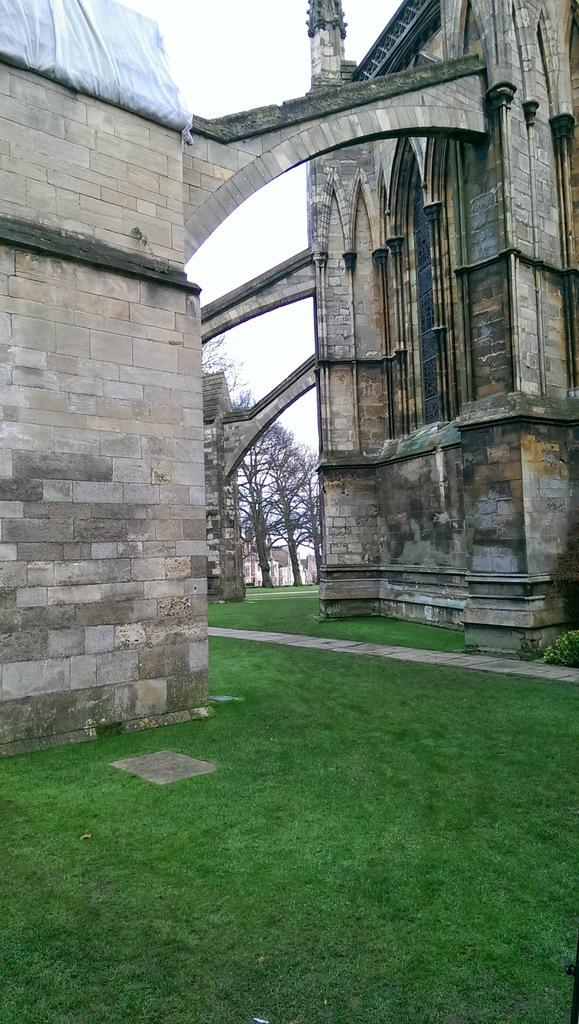What type of terrain is at the bottom of the image? There is grass at the bottom of the image. What structures can be seen in the middle of the image? There are buildings and trees in the middle of the image. What is visible at the top of the image? The sky is visible at the top of the image. What type of engine is used to power the science experiment in the image? There is no science experiment or engine present in the image. What type of experience can be gained from observing the grass in the image? The image does not convey any specific experience; it simply shows grass at the bottom of the image. 